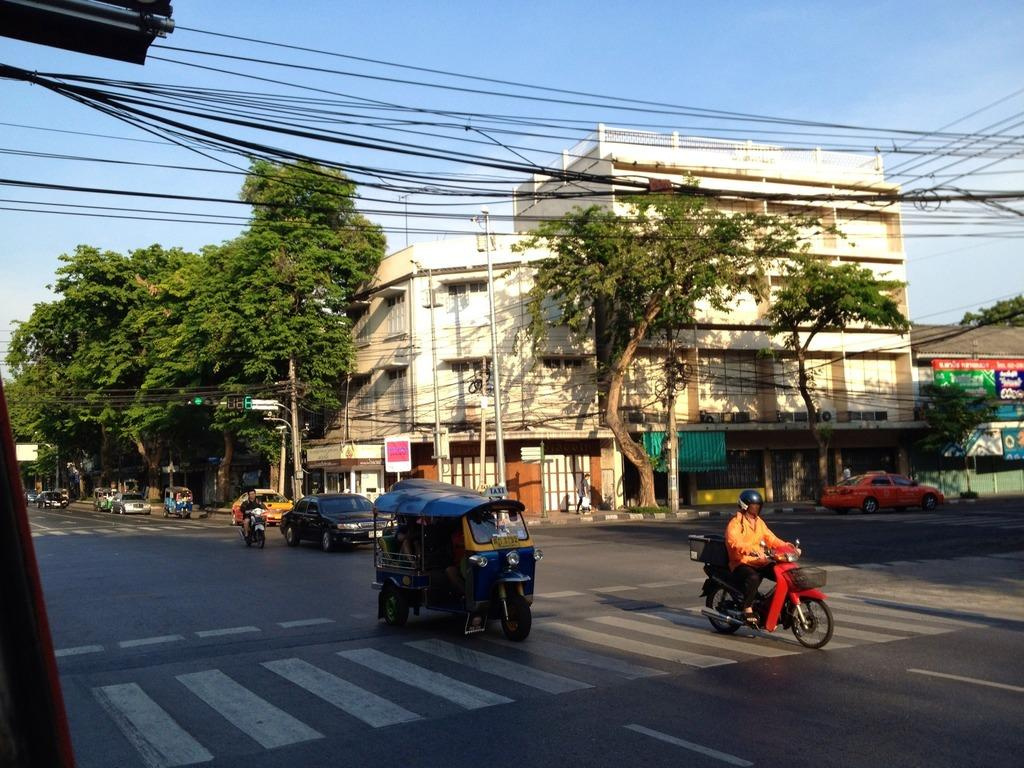What is happening in the image? There are vehicles moving on the road in the image. What can be seen in the distance in the image? There are buildings, trees, cables, poles, and the sky visible in the background of the image. How many types of structures can be seen in the background of the image? There are at least four types of structures visible in the background: buildings, trees, cables, and poles. What type of insurance is being discussed by the goats in the image? There are no goats present in the image, and therefore no discussion about insurance can be observed. 